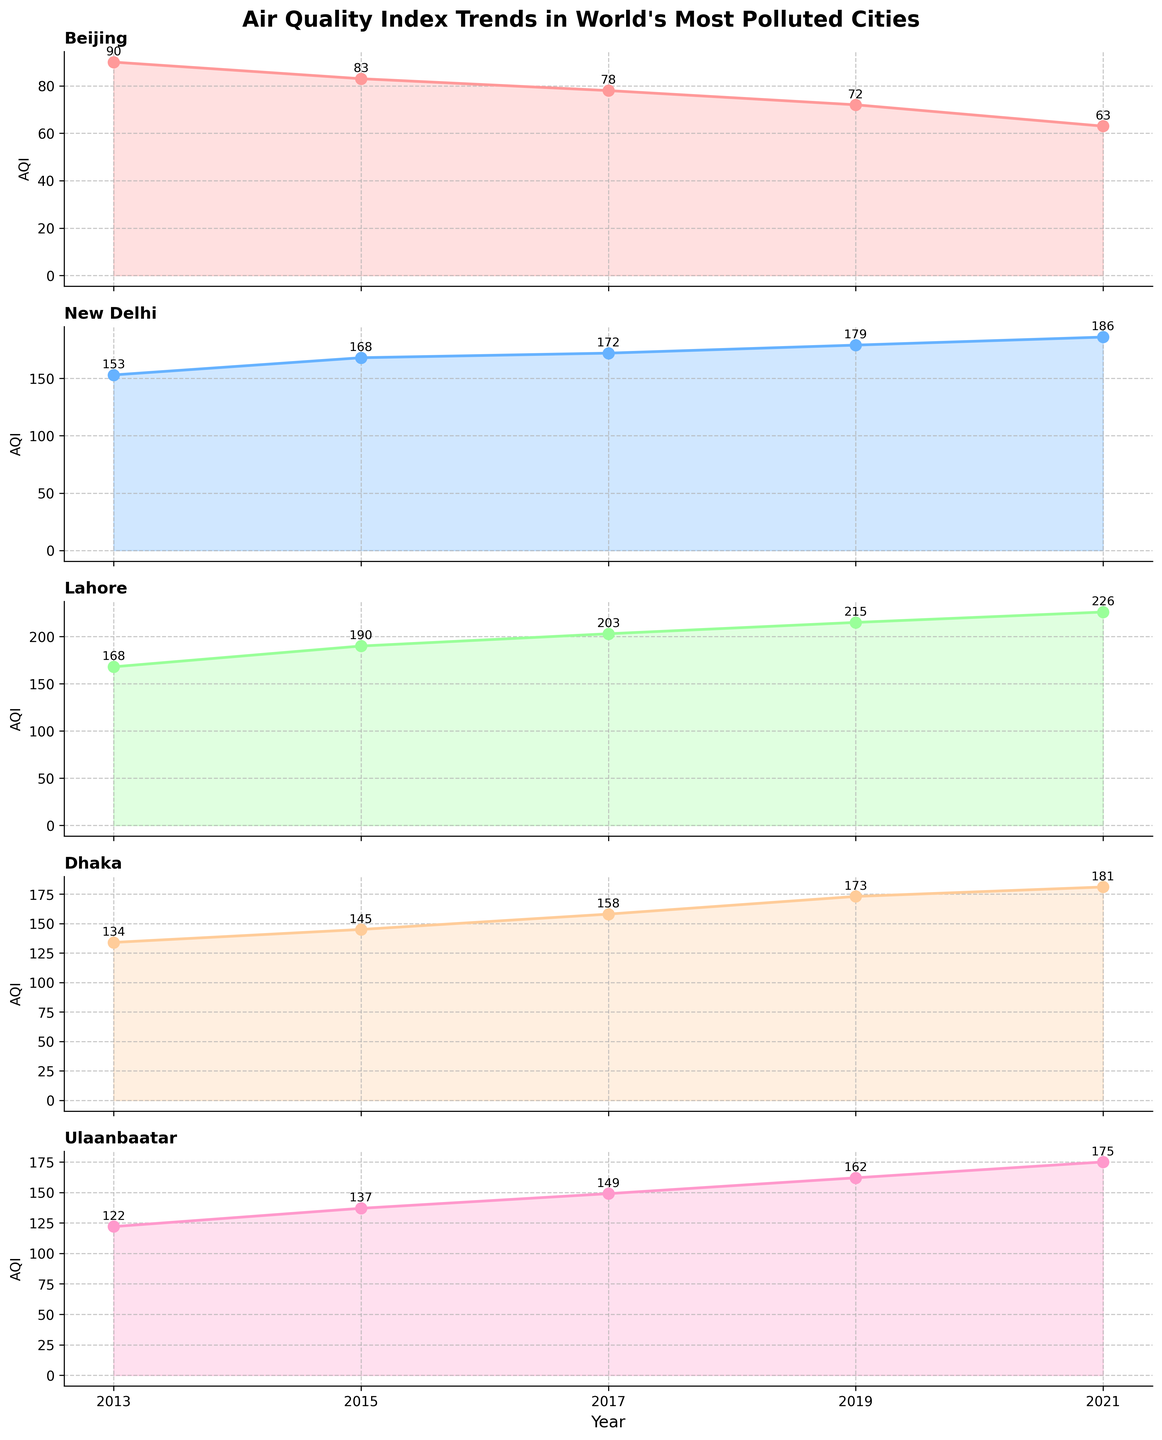what is the title of the figure? The title of the figure is located at the top center and it describes the main subject of the plot. According to the title above the plot, it is "Air Quality Index Trends in World's Most Polluted Cities."
Answer: Air Quality Index Trends in World's Most Polluted Cities Which city had the highest AQI in 2013? By looking at the line plots for 2013 on the horizontal subplots, we can see the AQI values. The subplot for New Delhi shows the highest AQI value of 168 for that year.
Answer: Lahore Which city's AQI decreased the most from 2013 to 2021? To solve this, we need to calculate the difference in AQI for each city between 2013 and 2021, then identify the city with the largest decrease. For Beijing: 90-63=27, New Delhi: 153-186=-33 (an increase), Lahore: 168-226=-58 (an increase), Dhaka: 134-181=-47 (an increase), Ulaanbaatar: 122-175=-53 (an increase). The one that decreased the most is Beijing.
Answer: Beijing What is the average AQI for Ulaanbaatar over the years presented? To find the average, sum up all the AQI values for Ulaanbaatar and divide by the number of years: (122 + 137 + 149 + 162 + 175) = 745. There are 5 data points, so 745 / 5 = 149.
Answer: 149 Is the overall AQI trend increasing or decreasing for New Delhi? By looking at the New Delhi subplot, we see from the beginning in 2013 (153) to the end in 2021 (186) that the AQI values are generally increasing over the years, indicating an overall increasing trend.
Answer: Increasing Which year shows the highest number of peak AQI values among the cities? Identify the years with the highest AQI for each city and count which year appears the most frequently. For Beijing, 2013; for New Delhi, 2021; for Lahore, 2021; for Dhaka, 2021; for Ulaanbaatar, 2021. The year 2021 has the highest number of peaks, with three cities reaching their peak AQI in this year.
Answer: 2021 Which city's AQI shows the most consistent trend over the years? The most consistent trend is indicated by the least fluctuation in AQI values. By observing the plots, Beijing's AQI shows a consistent decrease whereas others show more fluctuation.
Answer: Beijing 